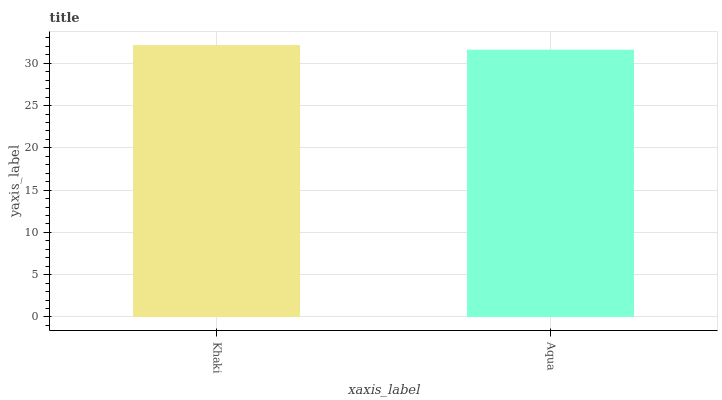Is Aqua the maximum?
Answer yes or no. No. Is Khaki greater than Aqua?
Answer yes or no. Yes. Is Aqua less than Khaki?
Answer yes or no. Yes. Is Aqua greater than Khaki?
Answer yes or no. No. Is Khaki less than Aqua?
Answer yes or no. No. Is Khaki the high median?
Answer yes or no. Yes. Is Aqua the low median?
Answer yes or no. Yes. Is Aqua the high median?
Answer yes or no. No. Is Khaki the low median?
Answer yes or no. No. 